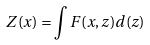Convert formula to latex. <formula><loc_0><loc_0><loc_500><loc_500>Z ( x ) = \int F ( x , z ) d ( z )</formula> 